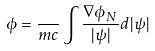Convert formula to latex. <formula><loc_0><loc_0><loc_500><loc_500>\phi = \frac { } { m c } \int \frac { \nabla \phi _ { N } } { | \psi | } d | \psi |</formula> 